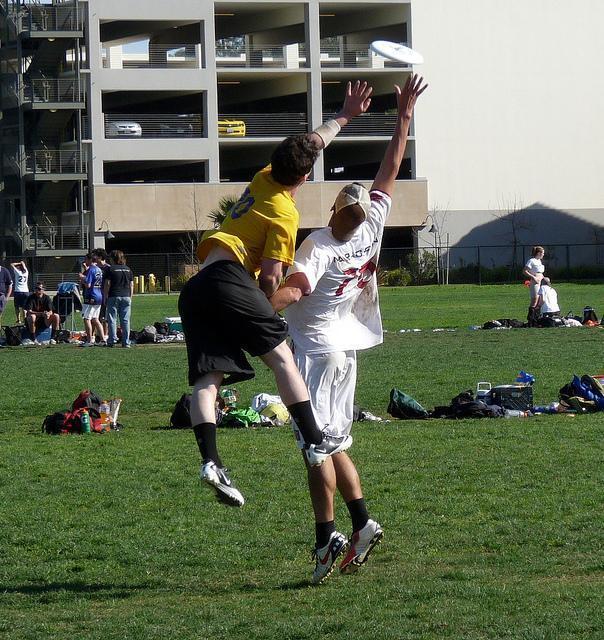How many people are lying on the floor?
Give a very brief answer. 0. How many people are there?
Give a very brief answer. 3. How many apples are there?
Give a very brief answer. 0. 